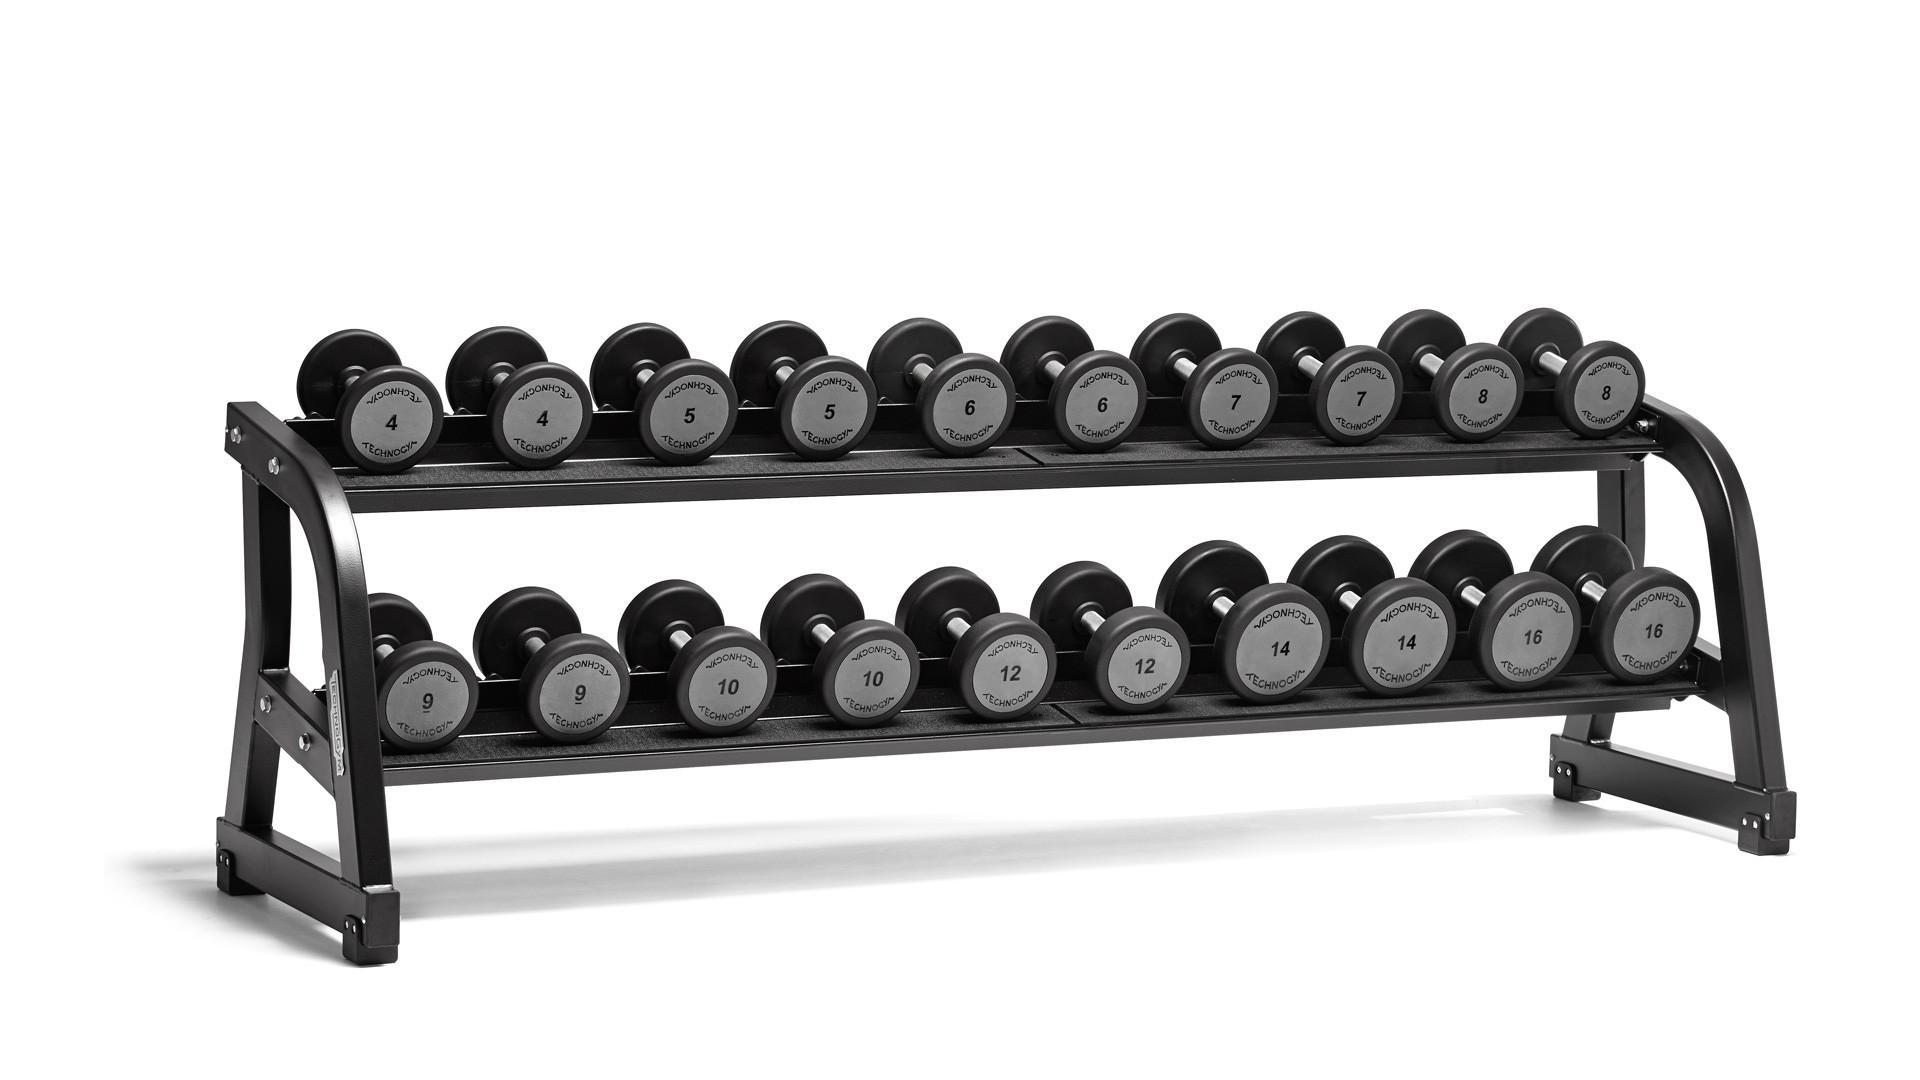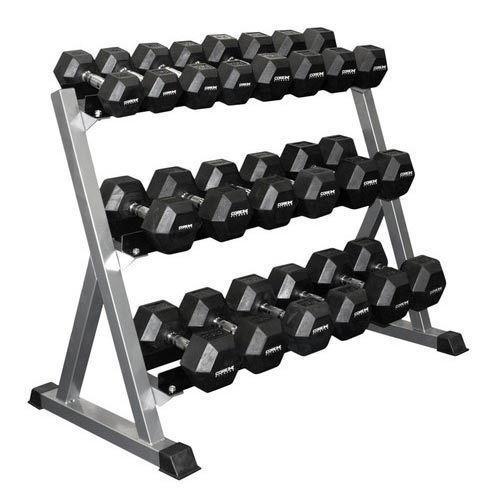The first image is the image on the left, the second image is the image on the right. Analyze the images presented: Is the assertion "One image shows a weight rack that holds three rows of dumbbells with hexagon-shaped ends." valid? Answer yes or no. Yes. The first image is the image on the left, the second image is the image on the right. Considering the images on both sides, is "The weights on the rack in the image on the left are round." valid? Answer yes or no. Yes. 